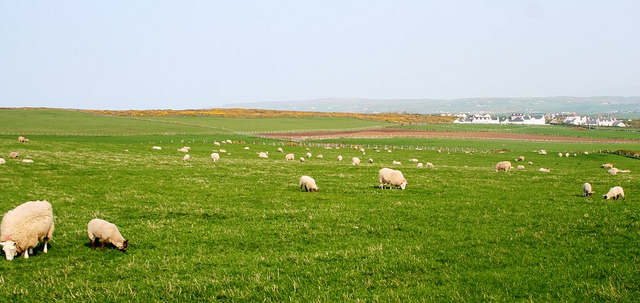<image>What landforms are in the back? I am not sure. There could be hills or houses. What landforms are in the back? I am not sure what landforms are in the back. However, it can be seen hills, meadows, homes, or houses. 